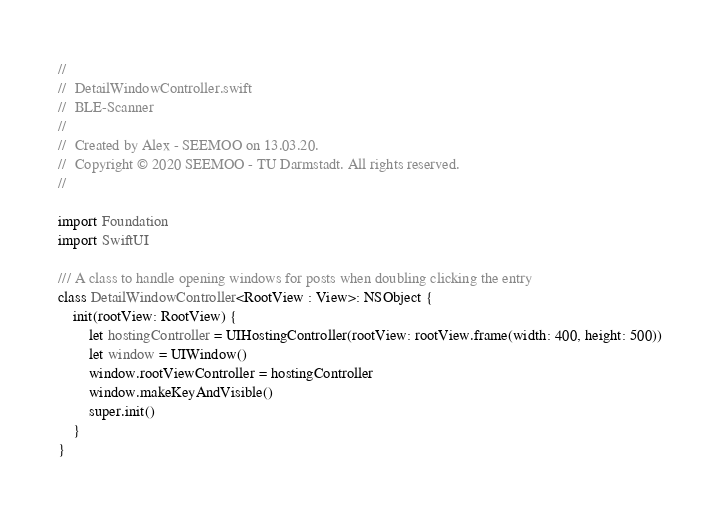Convert code to text. <code><loc_0><loc_0><loc_500><loc_500><_Swift_>//
//  DetailWindowController.swift
//  BLE-Scanner
//
//  Created by Alex - SEEMOO on 13.03.20.
//  Copyright © 2020 SEEMOO - TU Darmstadt. All rights reserved.
//

import Foundation
import SwiftUI

/// A class to handle opening windows for posts when doubling clicking the entry
class DetailWindowController<RootView : View>: NSObject {
    init(rootView: RootView) {
        let hostingController = UIHostingController(rootView: rootView.frame(width: 400, height: 500))
        let window = UIWindow()
        window.rootViewController = hostingController
        window.makeKeyAndVisible()
        super.init()
    }
}
</code> 